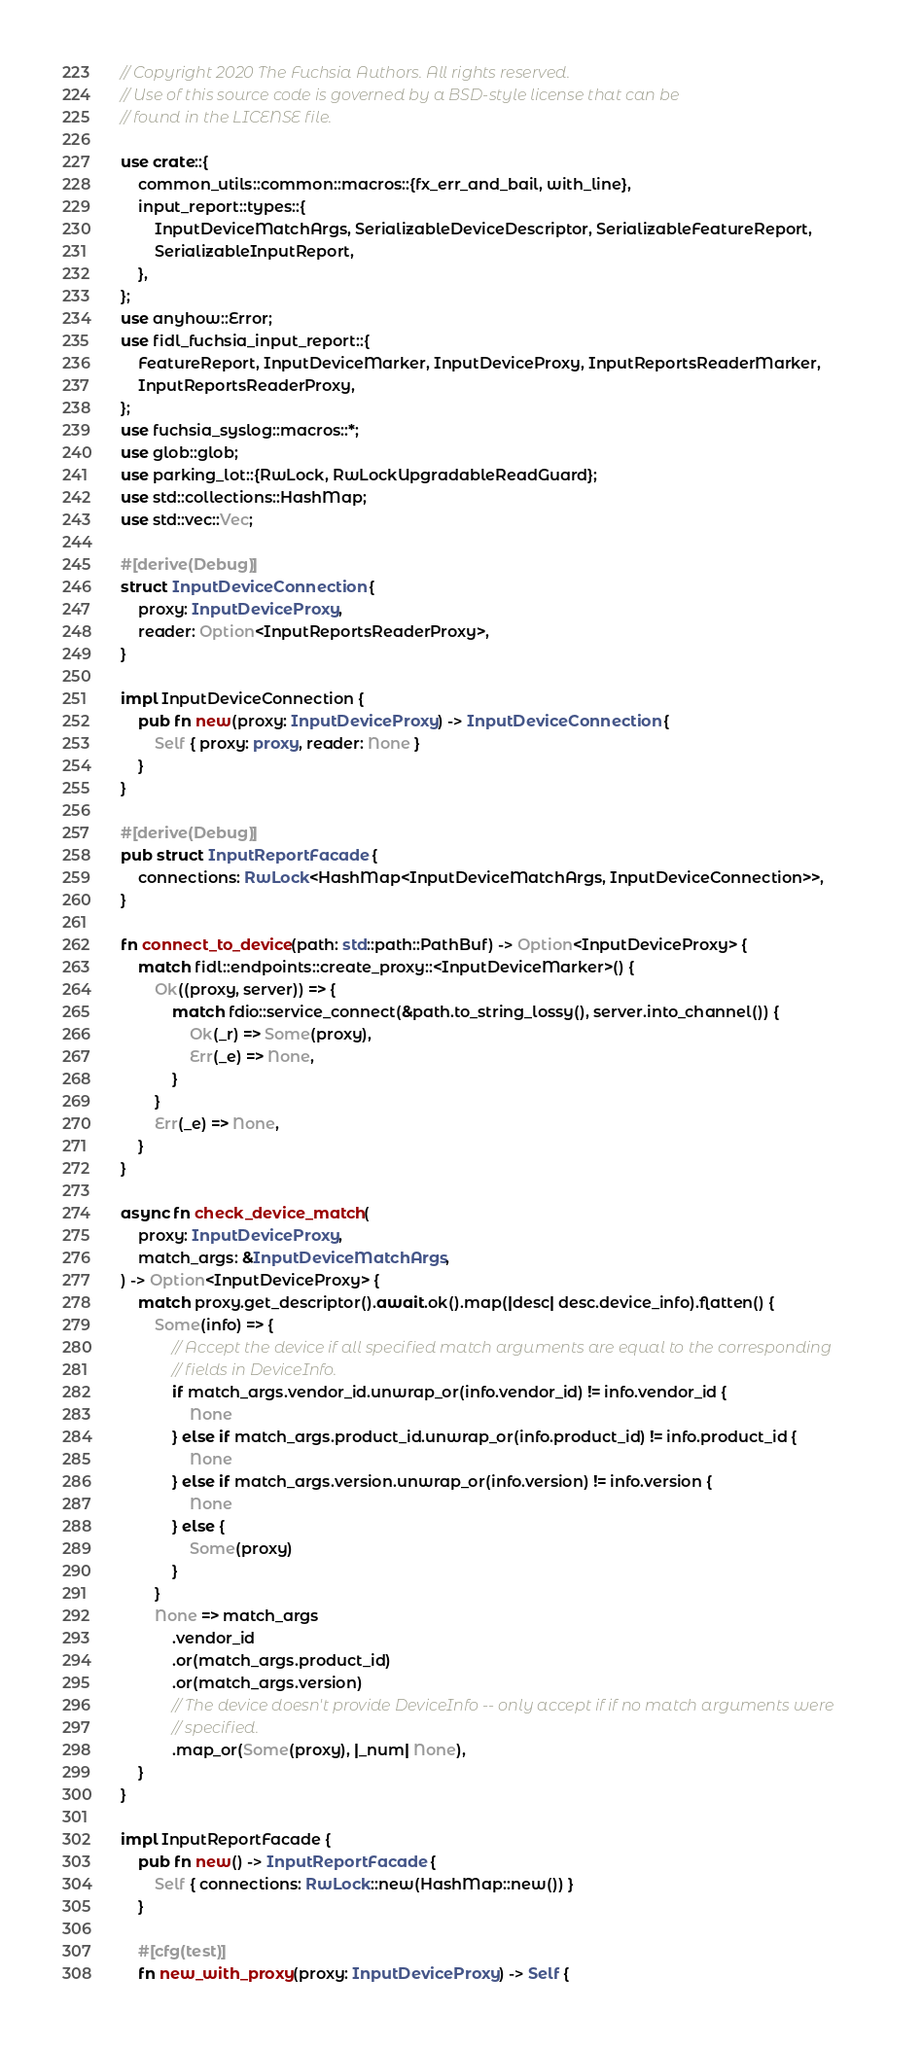<code> <loc_0><loc_0><loc_500><loc_500><_Rust_>// Copyright 2020 The Fuchsia Authors. All rights reserved.
// Use of this source code is governed by a BSD-style license that can be
// found in the LICENSE file.

use crate::{
    common_utils::common::macros::{fx_err_and_bail, with_line},
    input_report::types::{
        InputDeviceMatchArgs, SerializableDeviceDescriptor, SerializableFeatureReport,
        SerializableInputReport,
    },
};
use anyhow::Error;
use fidl_fuchsia_input_report::{
    FeatureReport, InputDeviceMarker, InputDeviceProxy, InputReportsReaderMarker,
    InputReportsReaderProxy,
};
use fuchsia_syslog::macros::*;
use glob::glob;
use parking_lot::{RwLock, RwLockUpgradableReadGuard};
use std::collections::HashMap;
use std::vec::Vec;

#[derive(Debug)]
struct InputDeviceConnection {
    proxy: InputDeviceProxy,
    reader: Option<InputReportsReaderProxy>,
}

impl InputDeviceConnection {
    pub fn new(proxy: InputDeviceProxy) -> InputDeviceConnection {
        Self { proxy: proxy, reader: None }
    }
}

#[derive(Debug)]
pub struct InputReportFacade {
    connections: RwLock<HashMap<InputDeviceMatchArgs, InputDeviceConnection>>,
}

fn connect_to_device(path: std::path::PathBuf) -> Option<InputDeviceProxy> {
    match fidl::endpoints::create_proxy::<InputDeviceMarker>() {
        Ok((proxy, server)) => {
            match fdio::service_connect(&path.to_string_lossy(), server.into_channel()) {
                Ok(_r) => Some(proxy),
                Err(_e) => None,
            }
        }
        Err(_e) => None,
    }
}

async fn check_device_match(
    proxy: InputDeviceProxy,
    match_args: &InputDeviceMatchArgs,
) -> Option<InputDeviceProxy> {
    match proxy.get_descriptor().await.ok().map(|desc| desc.device_info).flatten() {
        Some(info) => {
            // Accept the device if all specified match arguments are equal to the corresponding
            // fields in DeviceInfo.
            if match_args.vendor_id.unwrap_or(info.vendor_id) != info.vendor_id {
                None
            } else if match_args.product_id.unwrap_or(info.product_id) != info.product_id {
                None
            } else if match_args.version.unwrap_or(info.version) != info.version {
                None
            } else {
                Some(proxy)
            }
        }
        None => match_args
            .vendor_id
            .or(match_args.product_id)
            .or(match_args.version)
            // The device doesn't provide DeviceInfo -- only accept if if no match arguments were
            // specified.
            .map_or(Some(proxy), |_num| None),
    }
}

impl InputReportFacade {
    pub fn new() -> InputReportFacade {
        Self { connections: RwLock::new(HashMap::new()) }
    }

    #[cfg(test)]
    fn new_with_proxy(proxy: InputDeviceProxy) -> Self {</code> 